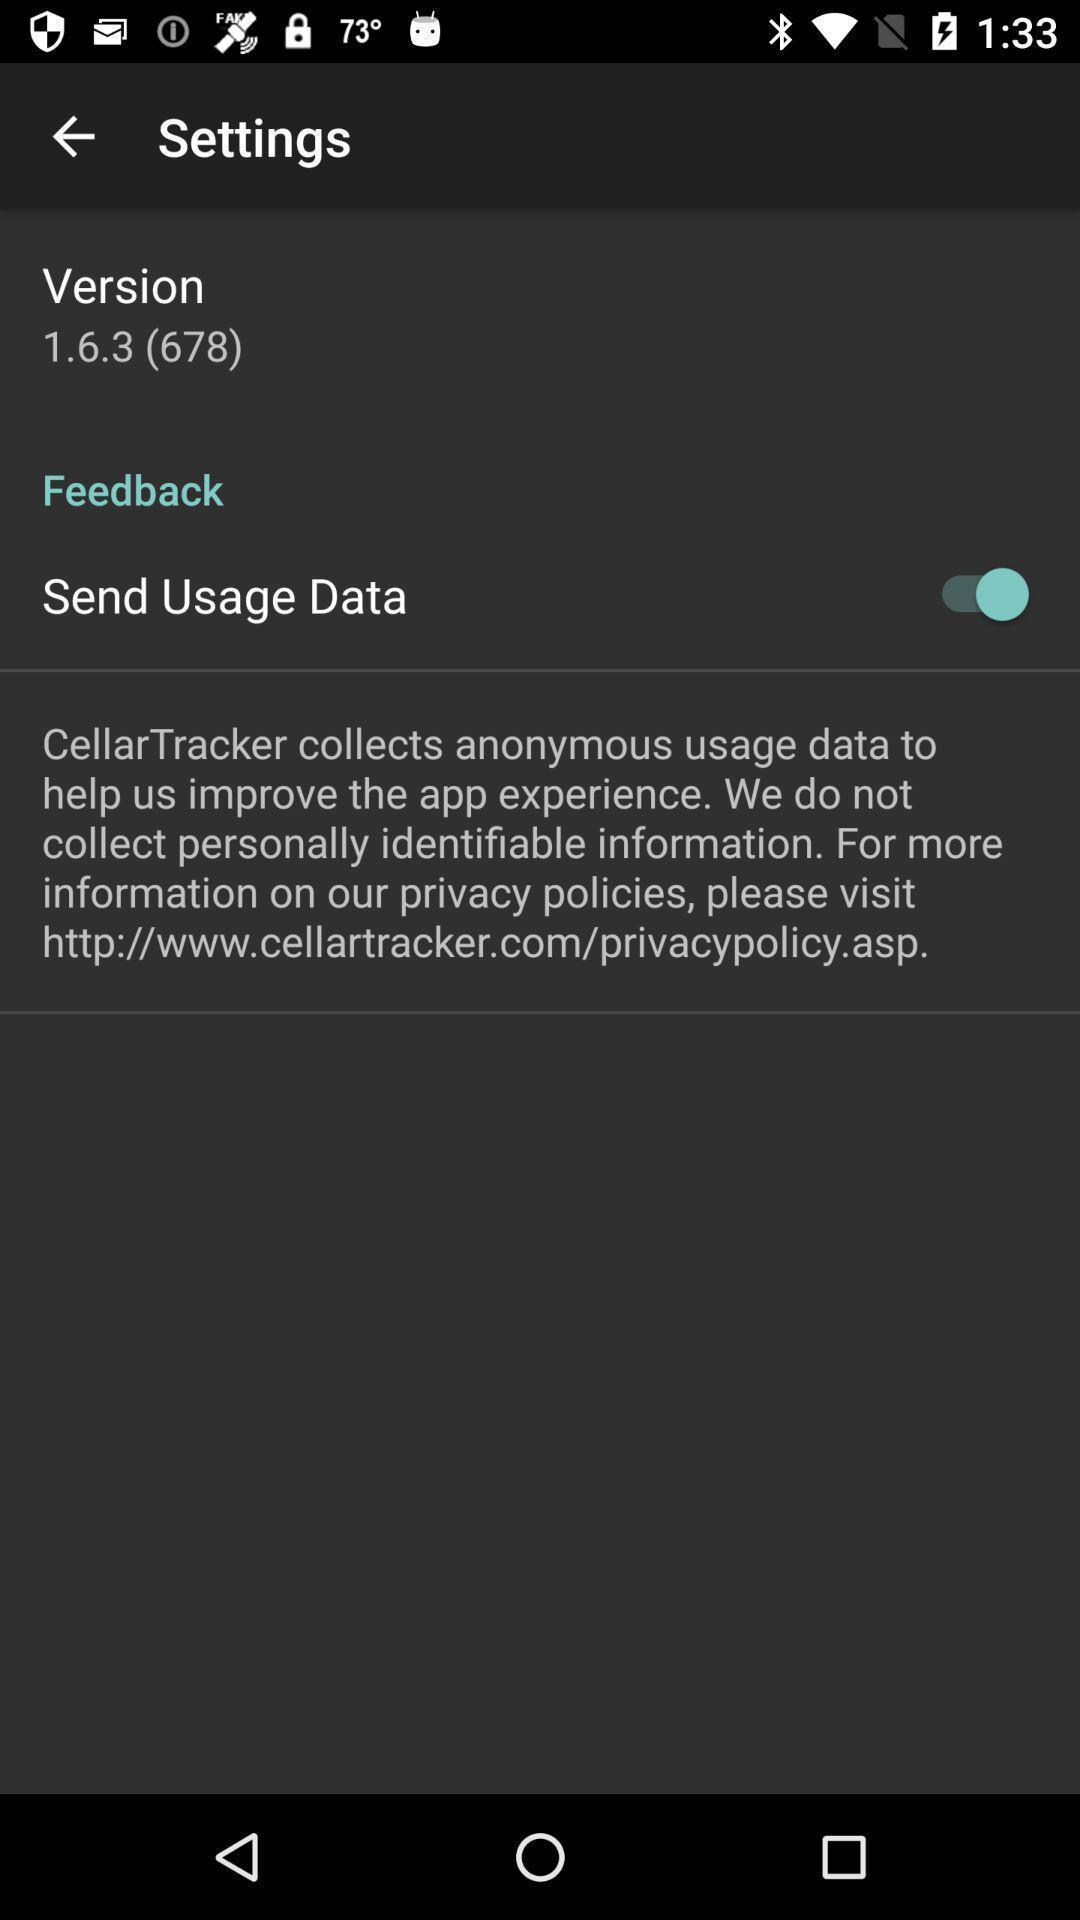Describe this image in words. Settings page. 